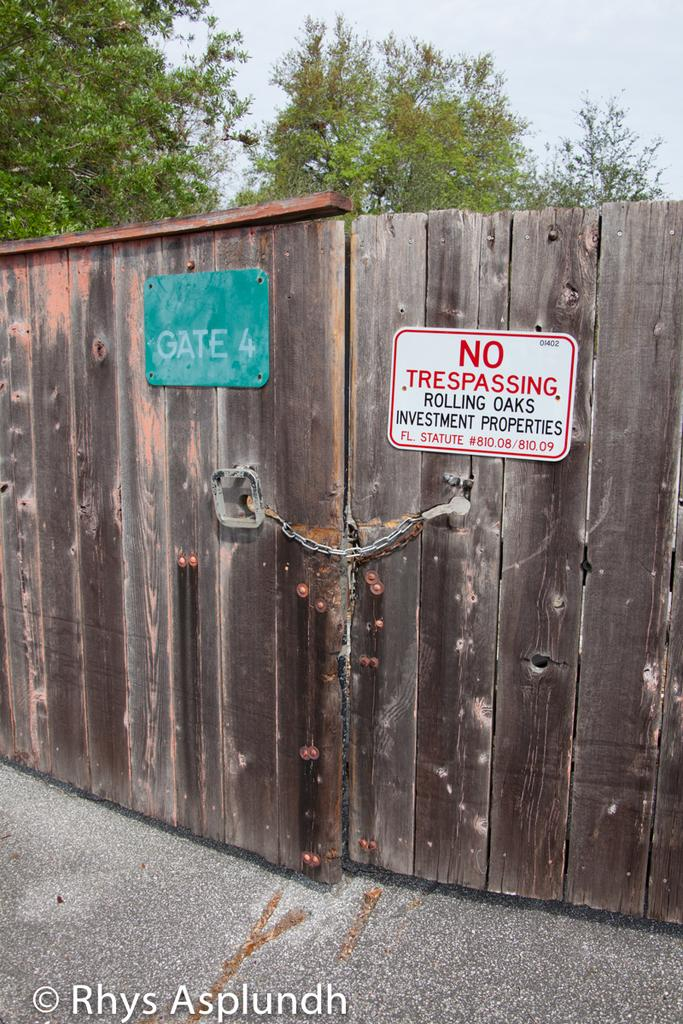What is the main feature of the image? There is a road in the image. What is located near the road? There is a wooden gate with chains in the image. What is written on the wooden gate? There are two boards with text on the gate. What can be seen in the background of the image? There are trees and a sky visible in the image. What type of wilderness can be seen in the image? There is no wilderness present in the image; it features a road, a wooden gate, and trees in the background. Can you hear anyone crying in the image? There is no sound present in the image, so it is impossible to determine if anyone is crying. 